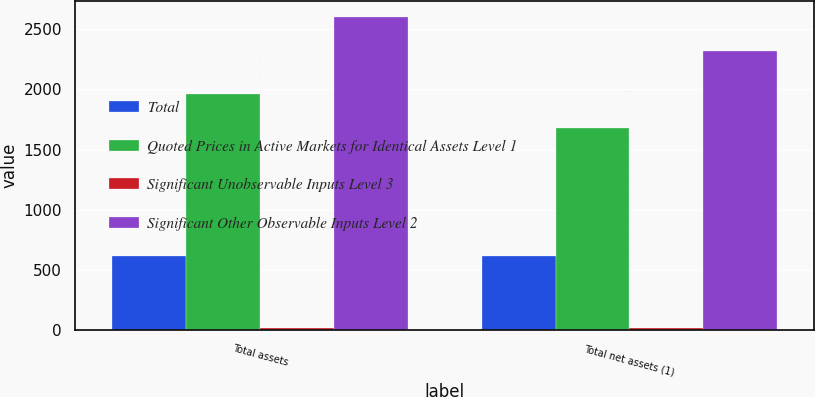Convert chart to OTSL. <chart><loc_0><loc_0><loc_500><loc_500><stacked_bar_chart><ecel><fcel>Total assets<fcel>Total net assets (1)<nl><fcel>Total<fcel>617<fcel>617<nl><fcel>Quoted Prices in Active Markets for Identical Assets Level 1<fcel>1964<fcel>1681<nl><fcel>Significant Unobservable Inputs Level 3<fcel>19<fcel>19<nl><fcel>Significant Other Observable Inputs Level 2<fcel>2600<fcel>2317<nl></chart> 